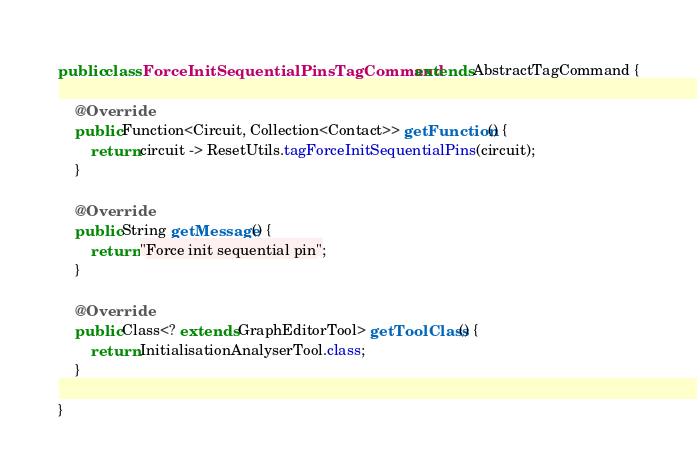Convert code to text. <code><loc_0><loc_0><loc_500><loc_500><_Java_>public class ForceInitSequentialPinsTagCommand extends AbstractTagCommand {

    @Override
    public Function<Circuit, Collection<Contact>> getFunction() {
        return circuit -> ResetUtils.tagForceInitSequentialPins(circuit);
    }

    @Override
    public String getMessage() {
        return "Force init sequential pin";
    }

    @Override
    public Class<? extends GraphEditorTool> getToolClass() {
        return InitialisationAnalyserTool.class;
    }

}
</code> 